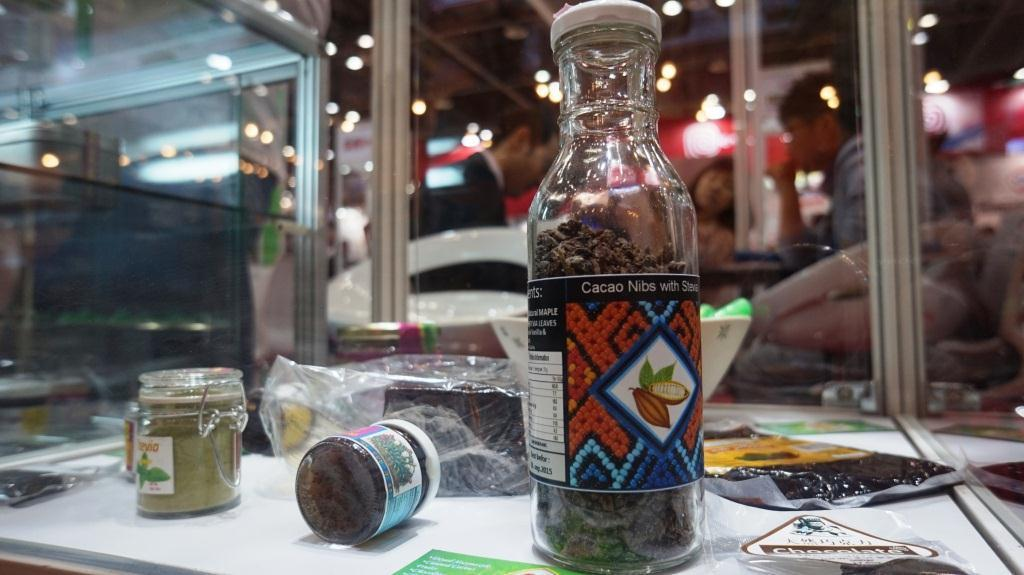What is the main object with a label in the image? There is a bottle with a label in the image. What other containers are on the table in the image? There are jars and a bowl on the table in the image. What else can be seen on the table in the image? There are packets on the table in the image. Can you describe the background of the image? There are people in the background of the image. What type of brain is visible in the image? There is no brain visible in the image. Is there a birthday celebration happening in the image? There is no indication of a birthday celebration in the image. 